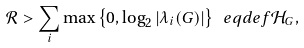Convert formula to latex. <formula><loc_0><loc_0><loc_500><loc_500>\mathcal { R } > \sum _ { i } \max \left \{ 0 , \log _ { 2 } \left | \lambda _ { i } ( G ) \right | \right \} \ e q d e f \mathcal { H } _ { G } ,</formula> 